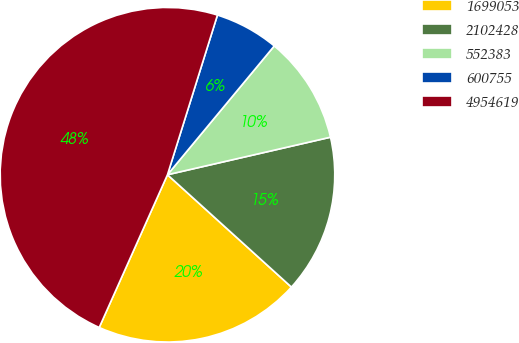Convert chart. <chart><loc_0><loc_0><loc_500><loc_500><pie_chart><fcel>1699053<fcel>2102428<fcel>552383<fcel>600755<fcel>4954619<nl><fcel>19.97%<fcel>15.32%<fcel>10.38%<fcel>6.19%<fcel>48.14%<nl></chart> 